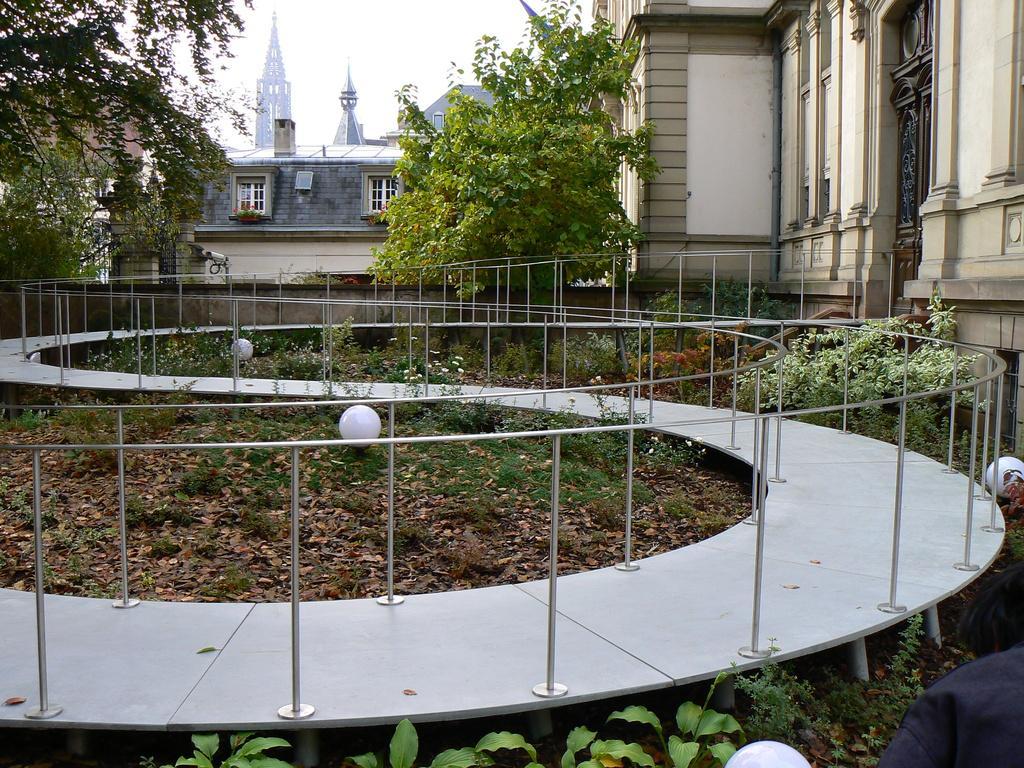How would you summarize this image in a sentence or two? The picture is taken outside a house. In the foreground of the picture there are plants, dry leaves, lights and railing. On the right there is a building. In the center of the picture there are trees and wall. In the background there is a cathedral and a house. It is sunny. 